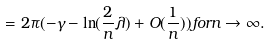Convert formula to latex. <formula><loc_0><loc_0><loc_500><loc_500>= 2 \pi ( - \gamma - \ln ( \frac { 2 } { n } \lambda ) + O ( \frac { 1 } { n } ) ) f o r n \rightarrow \infty .</formula> 